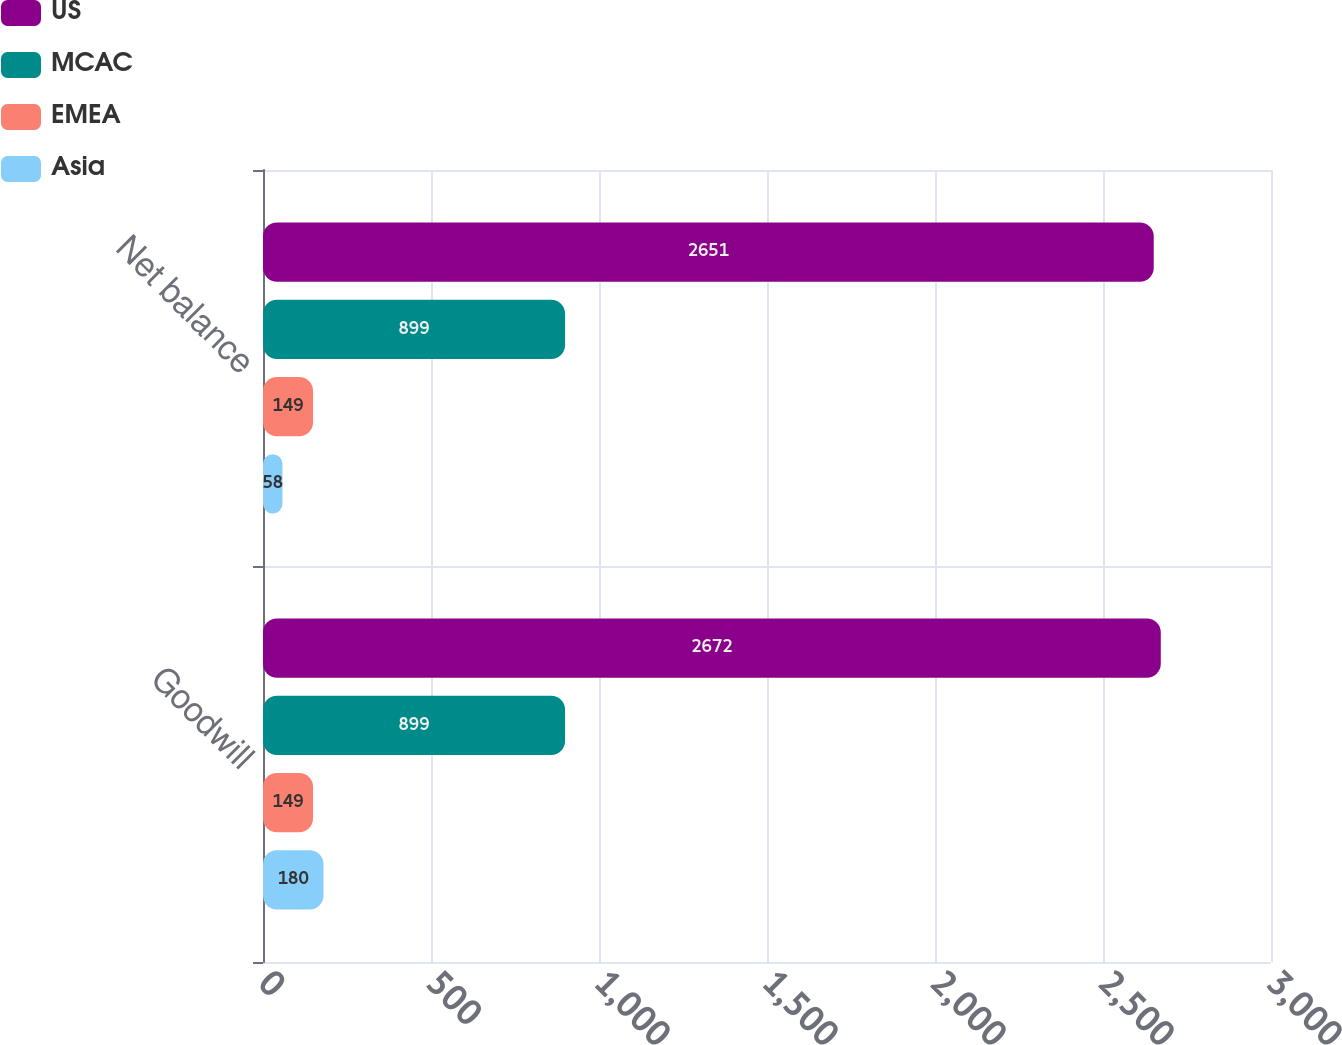Convert chart to OTSL. <chart><loc_0><loc_0><loc_500><loc_500><stacked_bar_chart><ecel><fcel>Goodwill<fcel>Net balance<nl><fcel>US<fcel>2672<fcel>2651<nl><fcel>MCAC<fcel>899<fcel>899<nl><fcel>EMEA<fcel>149<fcel>149<nl><fcel>Asia<fcel>180<fcel>58<nl></chart> 